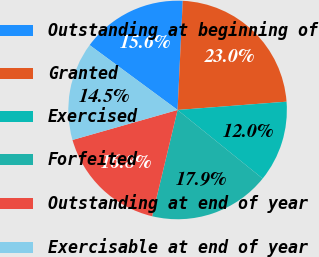Convert chart to OTSL. <chart><loc_0><loc_0><loc_500><loc_500><pie_chart><fcel>Outstanding at beginning of<fcel>Granted<fcel>Exercised<fcel>Forfeited<fcel>Outstanding at end of year<fcel>Exercisable at end of year<nl><fcel>15.64%<fcel>23.04%<fcel>12.01%<fcel>17.94%<fcel>16.83%<fcel>14.54%<nl></chart> 